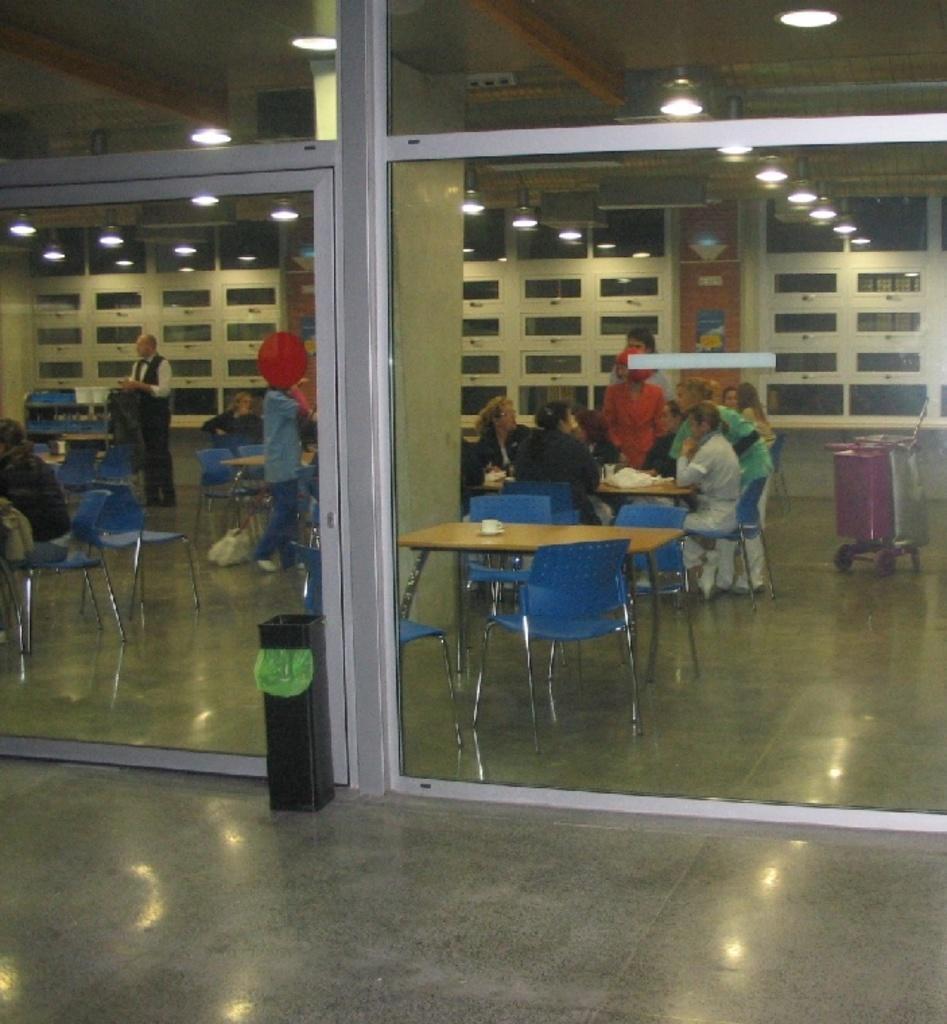In one or two sentences, can you explain what this image depicts? There are group of people sitting on the chair on the table there is a cup. In front there is a glass door and the bin on the floor. On the top there is a light. 